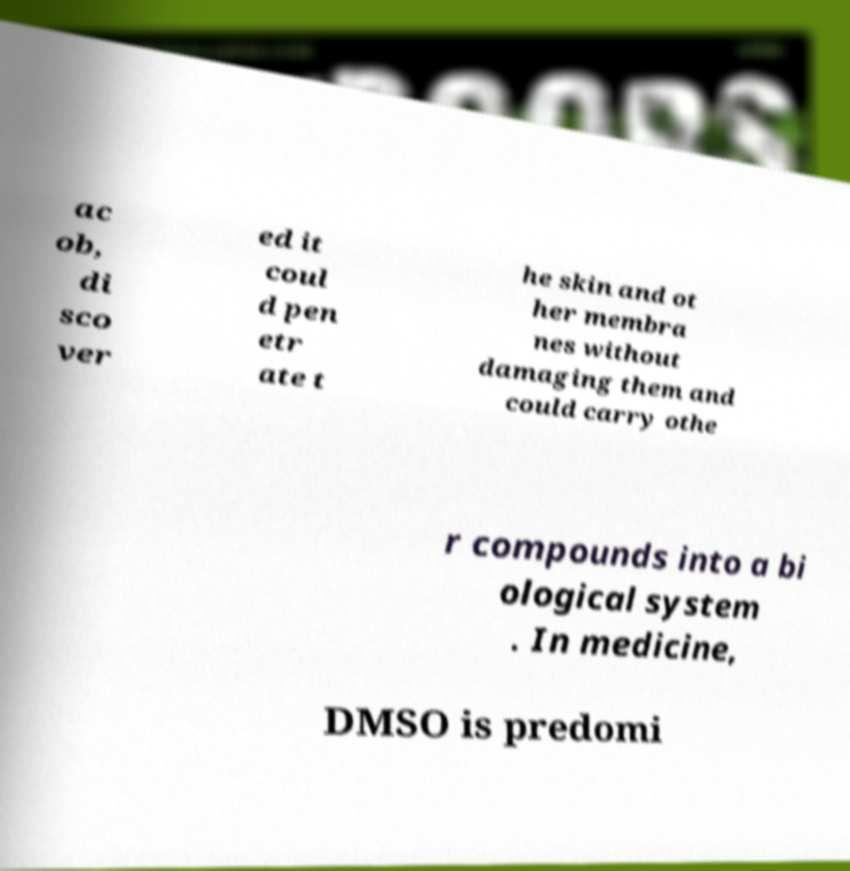For documentation purposes, I need the text within this image transcribed. Could you provide that? ac ob, di sco ver ed it coul d pen etr ate t he skin and ot her membra nes without damaging them and could carry othe r compounds into a bi ological system . In medicine, DMSO is predomi 